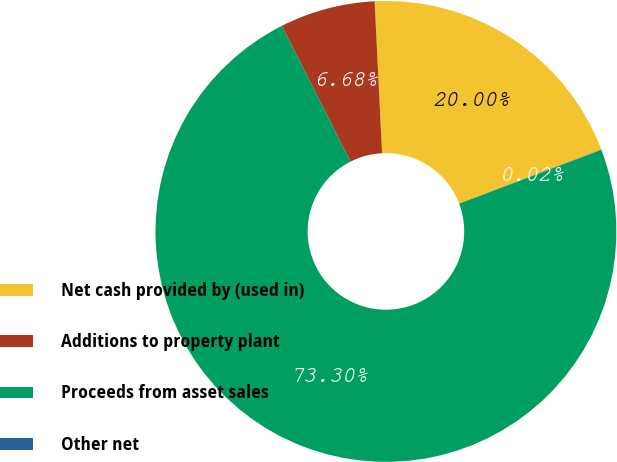<chart> <loc_0><loc_0><loc_500><loc_500><pie_chart><fcel>Net cash provided by (used in)<fcel>Additions to property plant<fcel>Proceeds from asset sales<fcel>Other net<nl><fcel>20.0%<fcel>6.68%<fcel>73.29%<fcel>0.02%<nl></chart> 